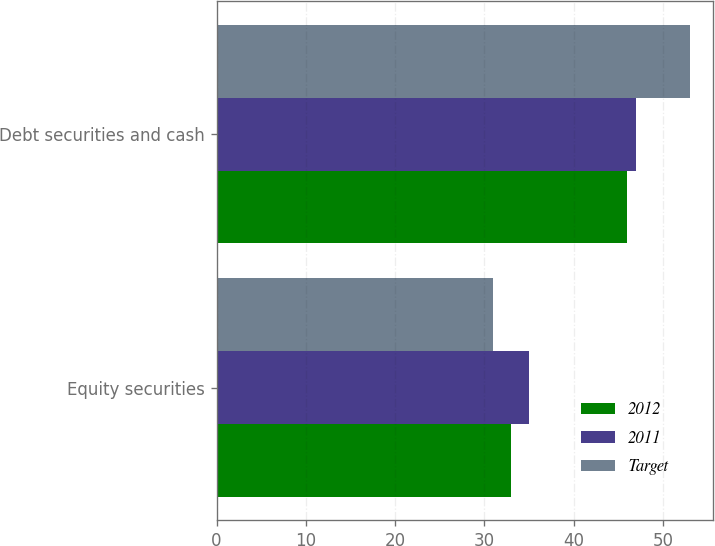<chart> <loc_0><loc_0><loc_500><loc_500><stacked_bar_chart><ecel><fcel>Equity securities<fcel>Debt securities and cash<nl><fcel>2012<fcel>33<fcel>46<nl><fcel>2011<fcel>35<fcel>47<nl><fcel>Target<fcel>31<fcel>53<nl></chart> 